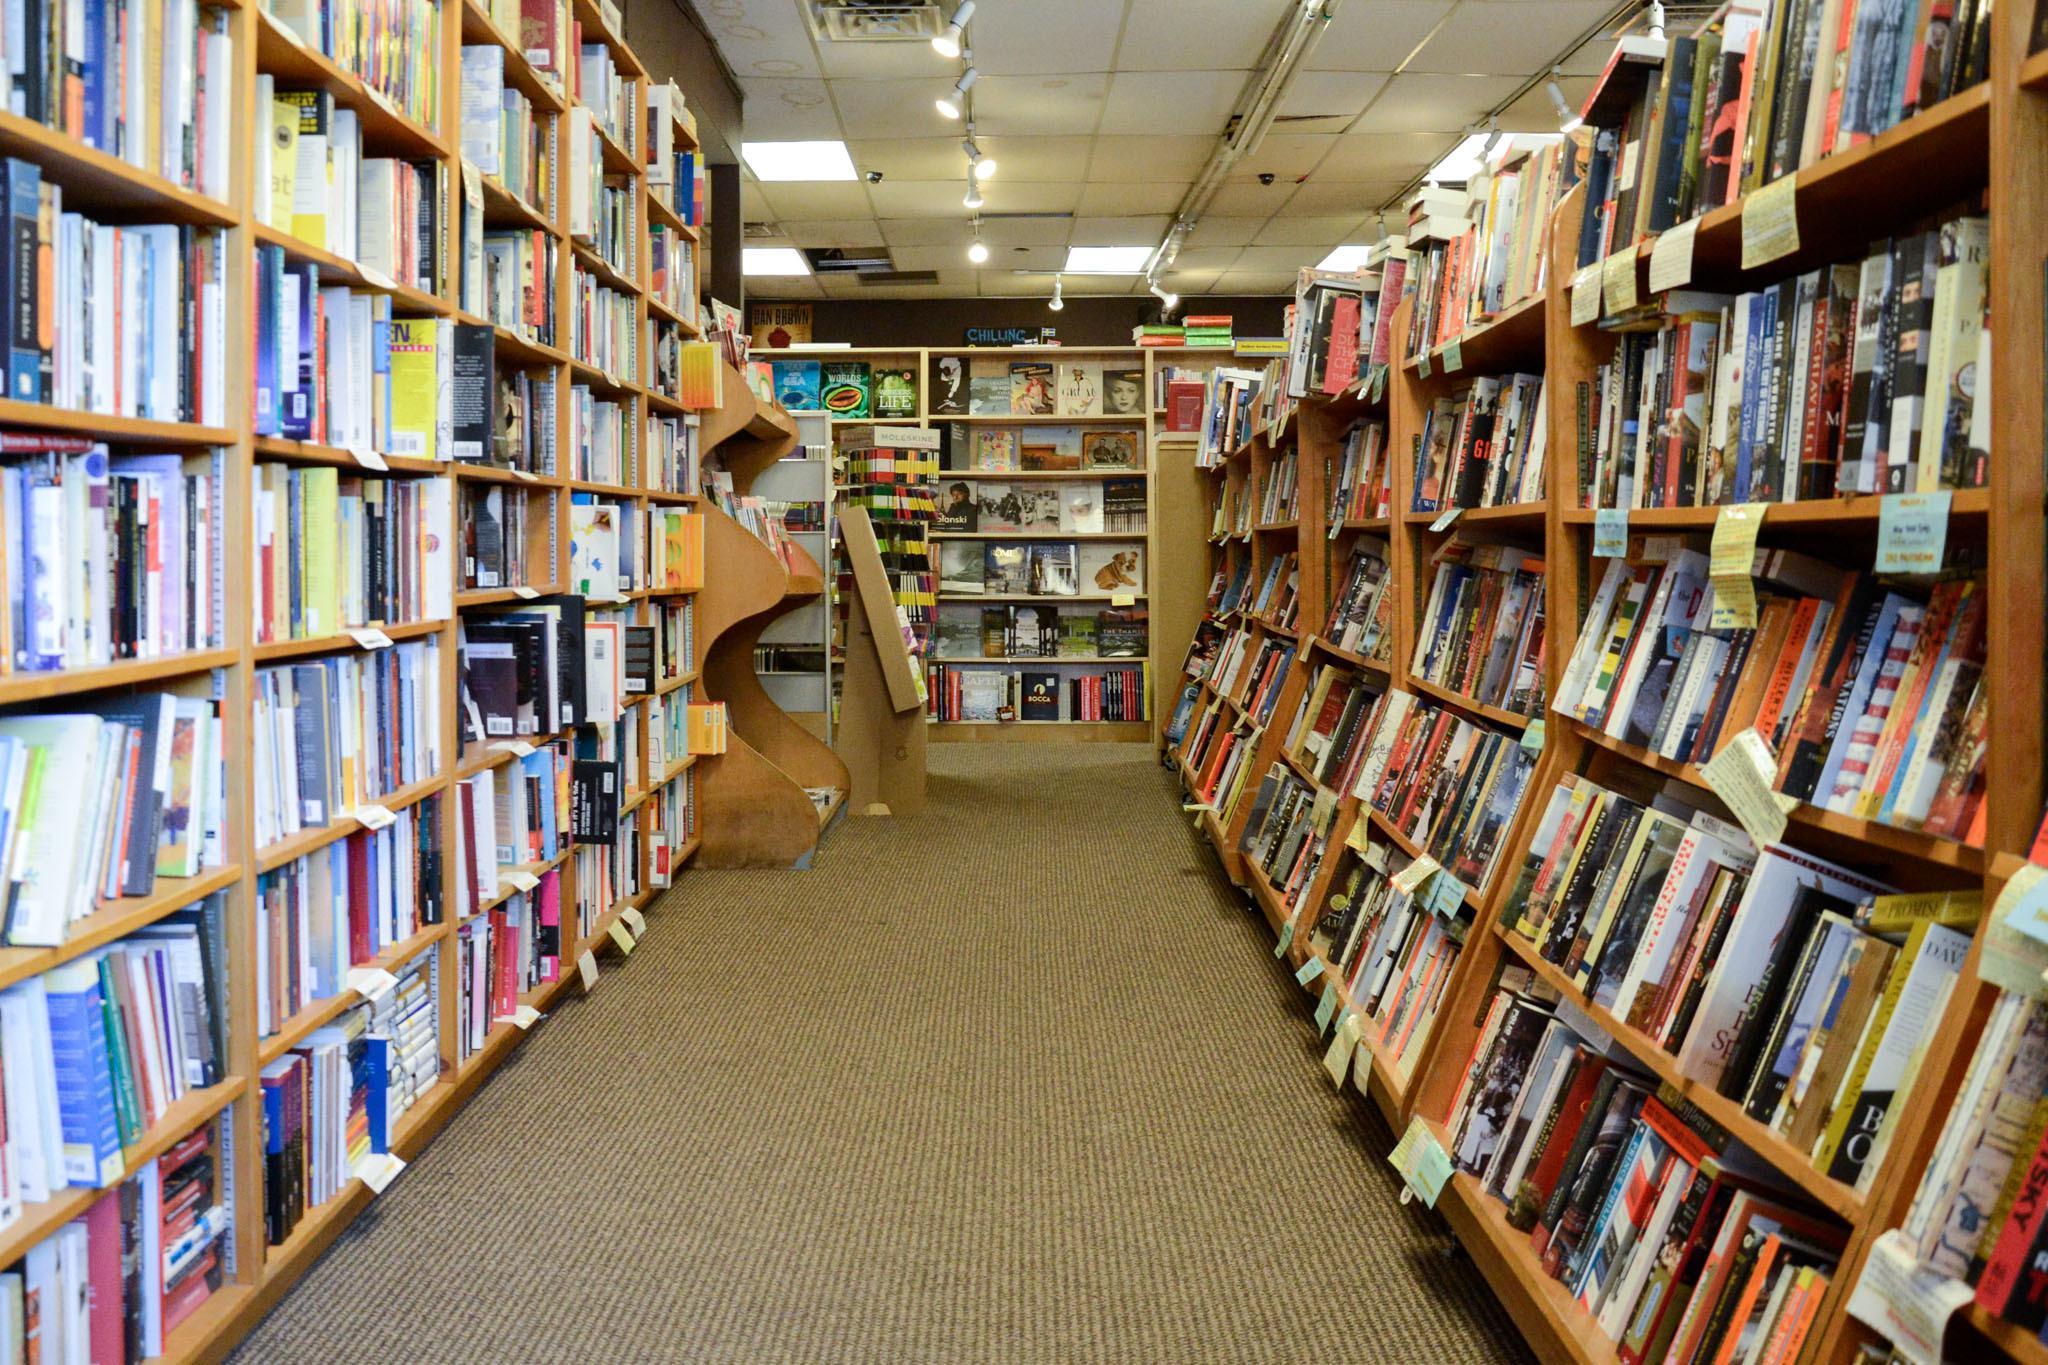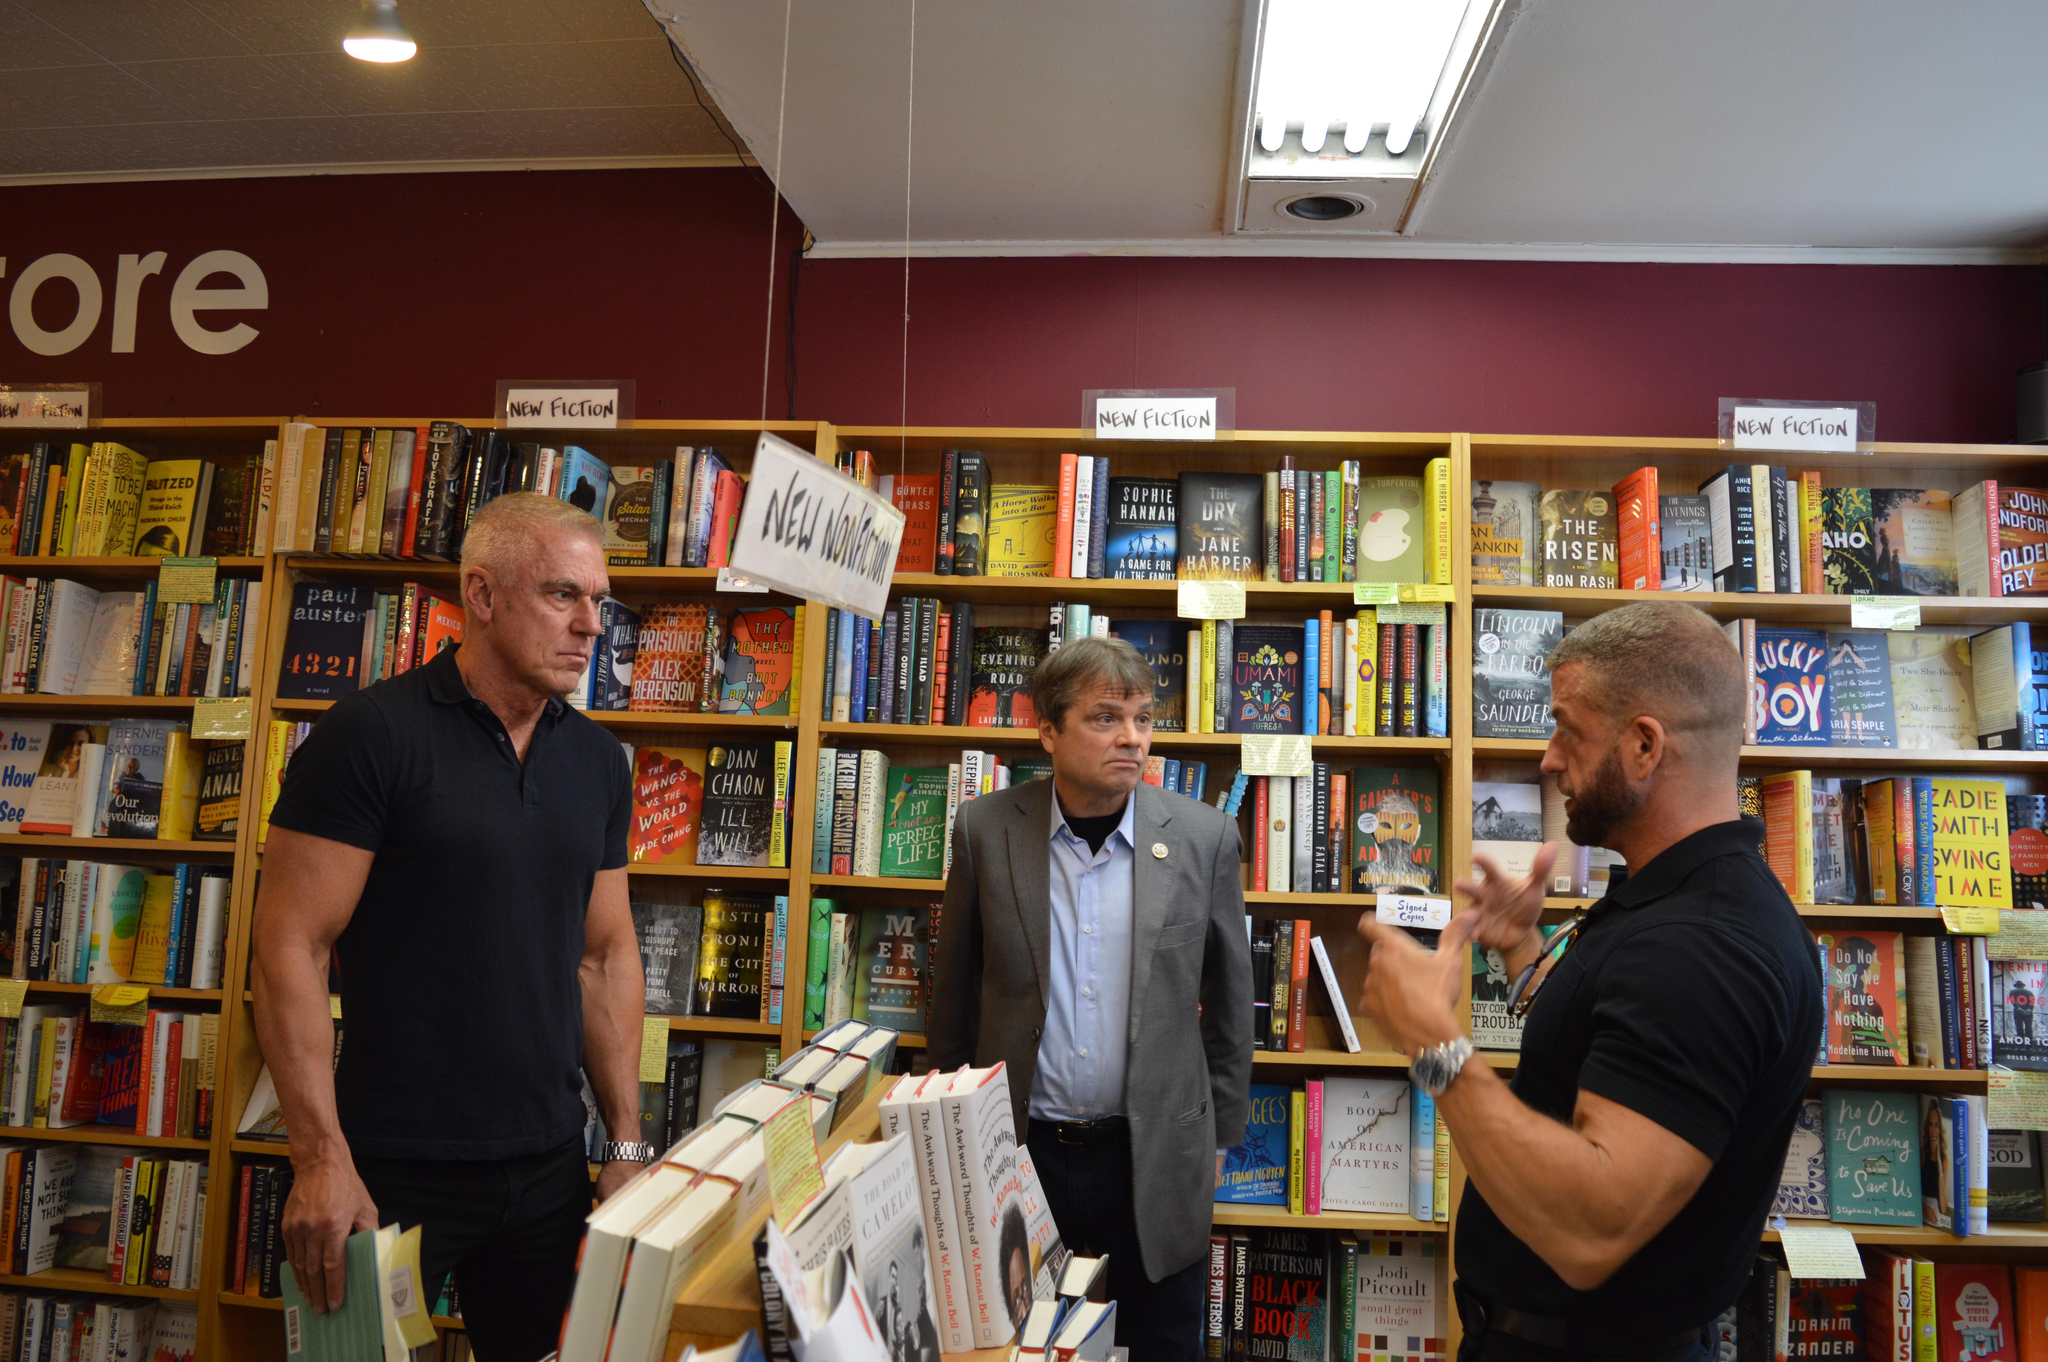The first image is the image on the left, the second image is the image on the right. Analyze the images presented: Is the assertion "A yellow sign sits on the sidewalk in the image on the right." valid? Answer yes or no. No. The first image is the image on the left, the second image is the image on the right. Considering the images on both sides, is "Both pictures show the inside of a bookstore." valid? Answer yes or no. Yes. 